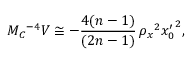Convert formula to latex. <formula><loc_0><loc_0><loc_500><loc_500>M _ { C ^ { - 4 } V \cong - \frac { 4 ( n - 1 ) } { ( 2 n - 1 ) } \, \rho _ { x ^ { 2 } { x _ { 0 } ^ { \prime } } ^ { 2 } ,</formula> 